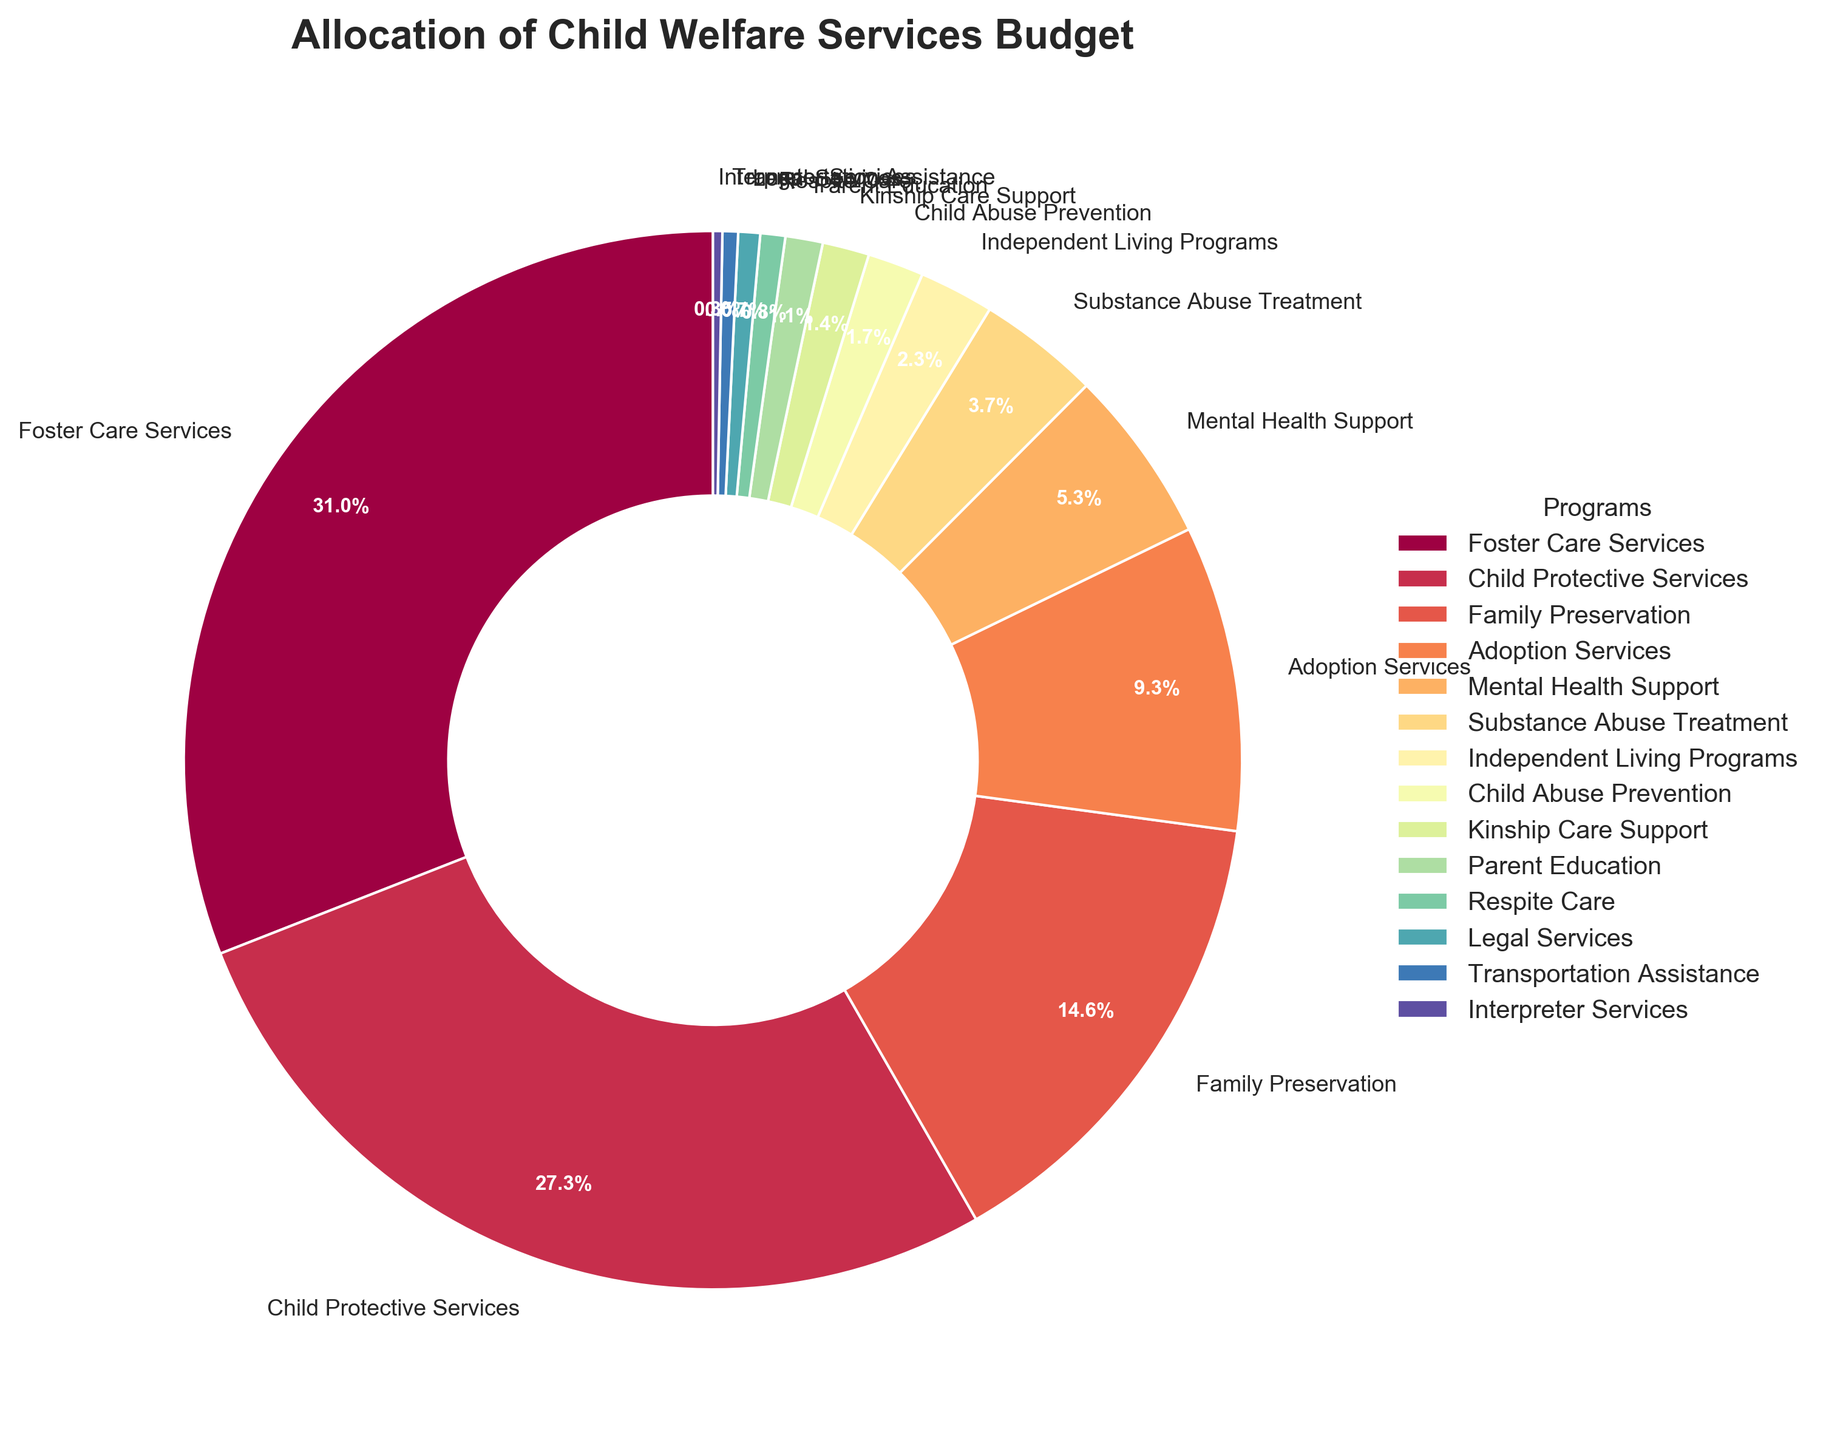What is the percentage allocated to Foster Care Services? Look at the slice labeled "Foster Care Services" on the pie chart, which shows a specific percentage for its budget allocation.
Answer: 32.5% Which program has a higher budget allocation: Child Protective Services or Family Preservation? Compare the slices labeled "Child Protective Services" and "Family Preservation" on the pie chart. Child Protective Services has a larger slice in terms of percentage.
Answer: Child Protective Services What is the combined budget allocation percentage for Adoption Services and Mental Health Support? Locate the slices for "Adoption Services" (9.8%) and "Mental Health Support" (5.6%) and sum these percentages: 9.8% + 5.6% = 15.4%.
Answer: 15.4% Are there any programs with a budget allocation of less than 1%? If so, name them. Look for slices showing budget percentages less than 1%. The programs with allocations under 1% are "Respite Care" (0.8%), "Legal Services" (0.7%), "Transportation Assistance" (0.5%), and "Interpreter Services" (0.3%).
Answer: Respite Care, Legal Services, Transportation Assistance, Interpreter Services Which program has the smallest budget allocation, and what is its percentage? Identify the smallest slice in the pie chart by size and label. "Interpreter Services" has the smallest allocation at 0.3%.
Answer: Interpreter Services, 0.3% How much more percentage does Foster Care Services receive compared to Parent Education? Find the percentages for "Foster Care Services" (32.5%) and "Parent Education" (1.2%), then calculate the difference: 32.5% - 1.2% = 31.3%.
Answer: 31.3% What is the average budget allocation percentage of the top three highest-funded programs? Identify the top three programs by budget allocation: Foster Care Services (32.5%), Child Protective Services (28.7%), and Family Preservation (15.3%). Calculate the average: (32.5% + 28.7% + 15.3%) / 3 = 25.5%.
Answer: 25.5% Is the budget allocation for Substance Abuse Treatment higher or lower than Mental Health Support, and by how much? Compare "Substance Abuse Treatment" (3.9%) with "Mental Health Support" (5.6%). Then, calculate the difference: 5.6% - 3.9% = 1.7%.
Answer: Lower, by 1.7% What is the total budget allocation percentage for all programs with less than a 2% allocation? Identify programs with less than 2% allocation: Independent Living Programs (2.4%), Child Abuse Prevention (1.8%), Kinship Care Support (1.5%), Parent Education (1.2%), Respite Care (0.8%), Legal Services (0.7%), Transportation Assistance (0.5%), and Interpreter Services (0.3%). Sum these percentages: 2.4% + 1.8% + 1.5% + 1.2% + 0.8% + 0.7% + 0.5% + 0.3% = 9.2%.
Answer: 9.2% Which two programs combined make up just over 10% of the budget? Look for the two slices whose percentages sum to just over 10%. "Adoption Services" (9.8%) and "Interpreter Services" (0.3%) combined make 10.1%.
Answer: Adoption Services and Interpreter Services 